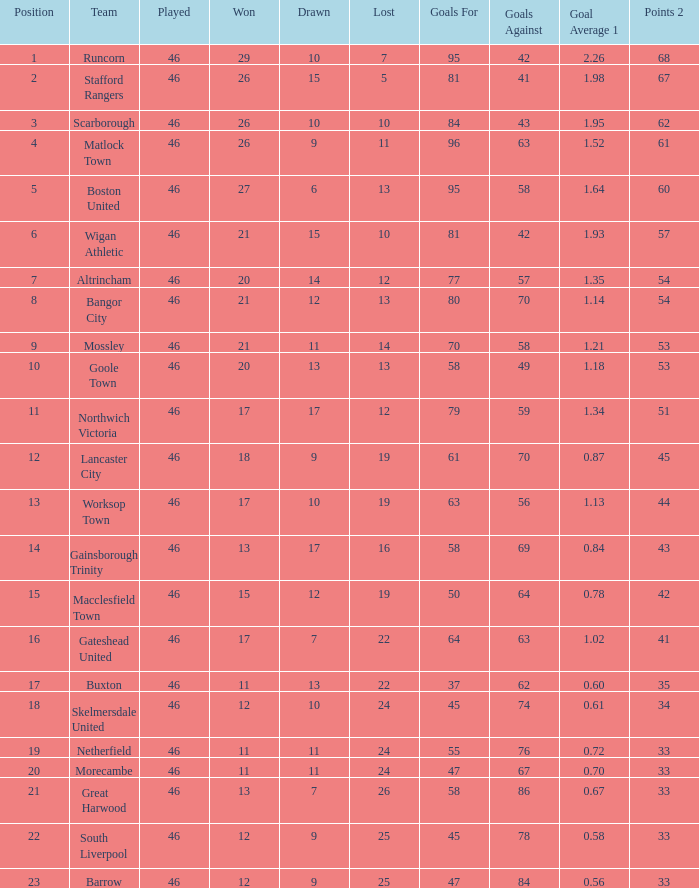How many occurrences did the lancaster city team perform? 1.0. 